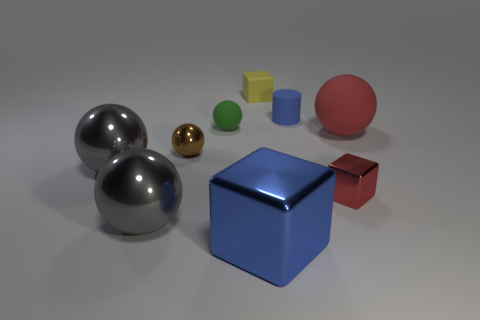Is the cylinder the same color as the large block?
Give a very brief answer. Yes. There is a tiny shiny sphere that is behind the tiny metallic thing on the right side of the yellow block; what color is it?
Ensure brevity in your answer.  Brown. How many small things are brown spheres or green spheres?
Provide a short and direct response. 2. There is a ball that is right of the tiny brown object and on the left side of the big red object; what is its color?
Give a very brief answer. Green. Is the material of the brown ball the same as the large blue object?
Your answer should be very brief. Yes. What is the shape of the brown metal object?
Provide a short and direct response. Sphere. What number of tiny brown spheres are in front of the red thing in front of the tiny object left of the tiny green ball?
Provide a succinct answer. 0. What is the color of the tiny matte object that is the same shape as the big blue metal thing?
Give a very brief answer. Yellow. There is a blue thing in front of the block right of the small yellow rubber object behind the large blue object; what shape is it?
Make the answer very short. Cube. What is the size of the shiny thing that is left of the cylinder and to the right of the tiny brown metallic sphere?
Provide a succinct answer. Large. 